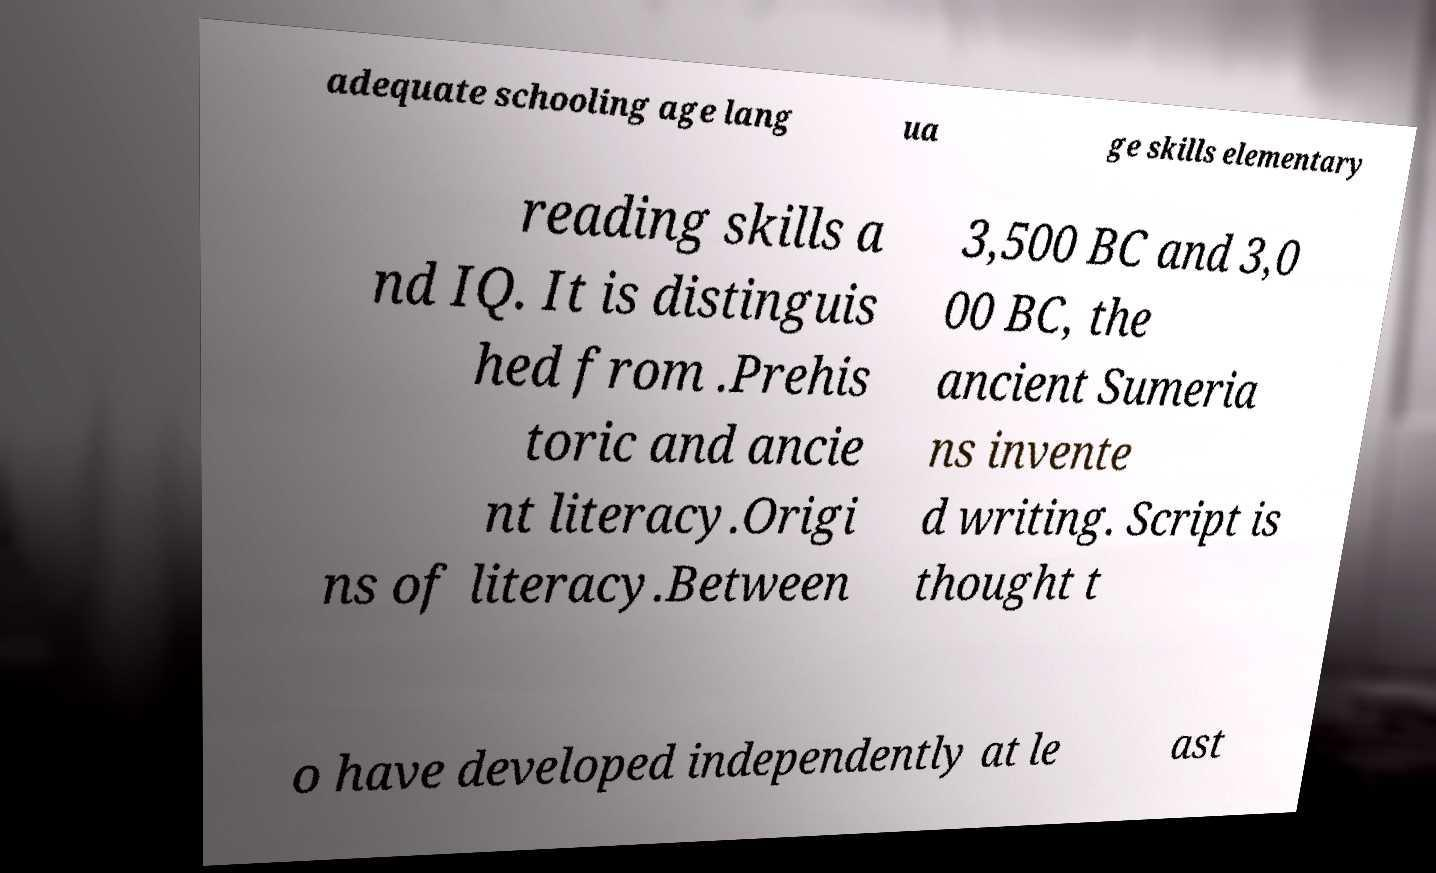Please identify and transcribe the text found in this image. adequate schooling age lang ua ge skills elementary reading skills a nd IQ. It is distinguis hed from .Prehis toric and ancie nt literacy.Origi ns of literacy.Between 3,500 BC and 3,0 00 BC, the ancient Sumeria ns invente d writing. Script is thought t o have developed independently at le ast 